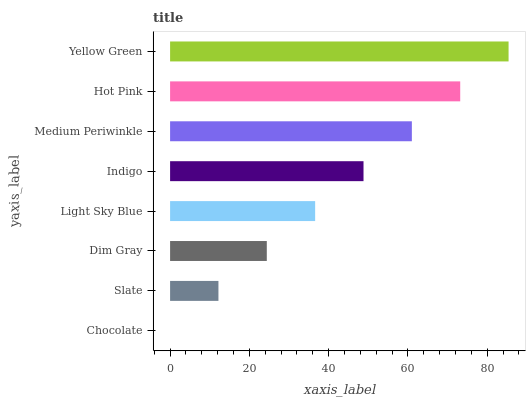Is Chocolate the minimum?
Answer yes or no. Yes. Is Yellow Green the maximum?
Answer yes or no. Yes. Is Slate the minimum?
Answer yes or no. No. Is Slate the maximum?
Answer yes or no. No. Is Slate greater than Chocolate?
Answer yes or no. Yes. Is Chocolate less than Slate?
Answer yes or no. Yes. Is Chocolate greater than Slate?
Answer yes or no. No. Is Slate less than Chocolate?
Answer yes or no. No. Is Indigo the high median?
Answer yes or no. Yes. Is Light Sky Blue the low median?
Answer yes or no. Yes. Is Slate the high median?
Answer yes or no. No. Is Indigo the low median?
Answer yes or no. No. 